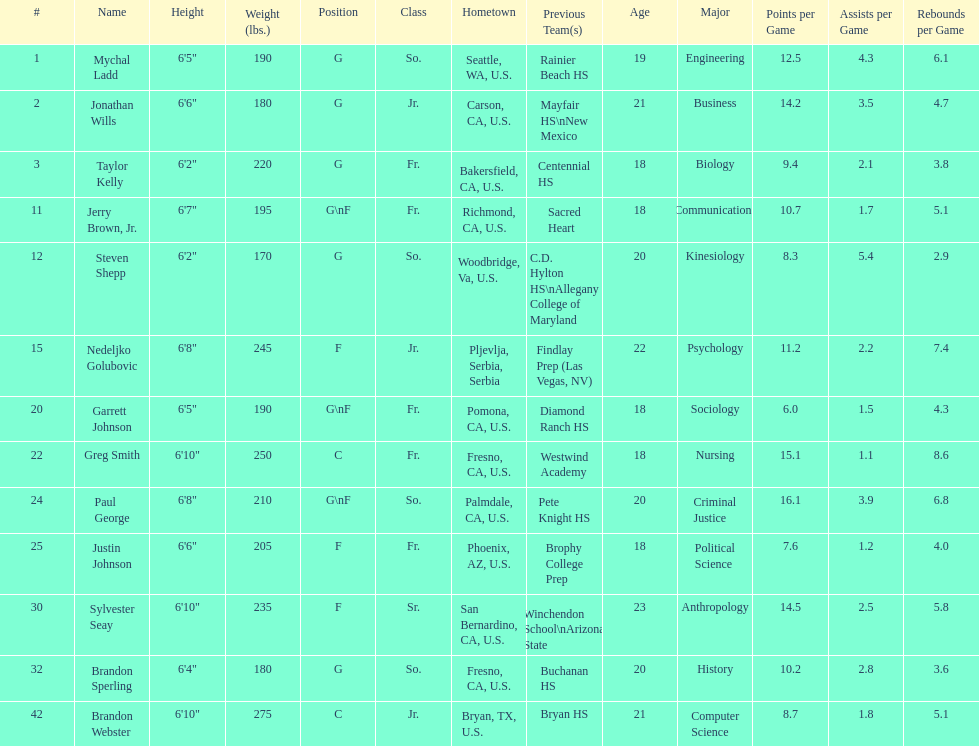Is the number of freshmen (fr.) greater than, equal to, or less than the number of juniors (jr.)? Greater. 